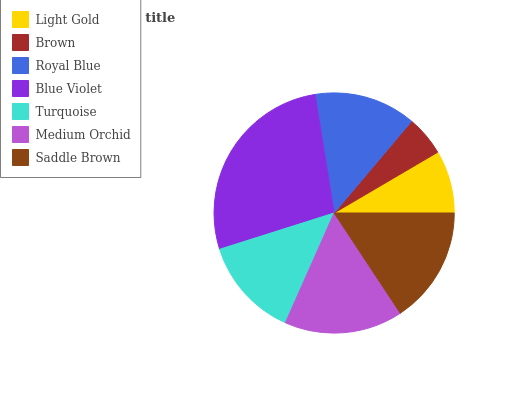Is Brown the minimum?
Answer yes or no. Yes. Is Blue Violet the maximum?
Answer yes or no. Yes. Is Royal Blue the minimum?
Answer yes or no. No. Is Royal Blue the maximum?
Answer yes or no. No. Is Royal Blue greater than Brown?
Answer yes or no. Yes. Is Brown less than Royal Blue?
Answer yes or no. Yes. Is Brown greater than Royal Blue?
Answer yes or no. No. Is Royal Blue less than Brown?
Answer yes or no. No. Is Royal Blue the high median?
Answer yes or no. Yes. Is Royal Blue the low median?
Answer yes or no. Yes. Is Brown the high median?
Answer yes or no. No. Is Saddle Brown the low median?
Answer yes or no. No. 